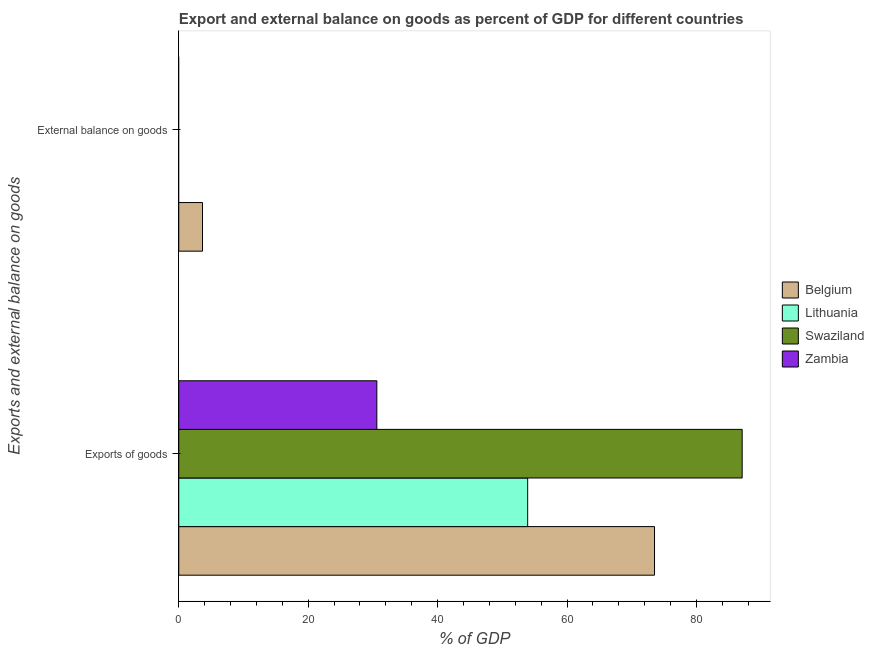Are the number of bars on each tick of the Y-axis equal?
Provide a succinct answer. No. How many bars are there on the 2nd tick from the bottom?
Make the answer very short. 1. What is the label of the 2nd group of bars from the top?
Provide a succinct answer. Exports of goods. What is the external balance on goods as percentage of gdp in Belgium?
Your answer should be very brief. 3.67. Across all countries, what is the maximum export of goods as percentage of gdp?
Provide a short and direct response. 87.07. Across all countries, what is the minimum export of goods as percentage of gdp?
Make the answer very short. 30.61. What is the total export of goods as percentage of gdp in the graph?
Make the answer very short. 245.12. What is the difference between the export of goods as percentage of gdp in Lithuania and that in Belgium?
Your answer should be compact. -19.6. What is the difference between the export of goods as percentage of gdp in Belgium and the external balance on goods as percentage of gdp in Swaziland?
Keep it short and to the point. 73.52. What is the average external balance on goods as percentage of gdp per country?
Provide a short and direct response. 0.92. What is the difference between the export of goods as percentage of gdp and external balance on goods as percentage of gdp in Belgium?
Your answer should be very brief. 69.85. In how many countries, is the external balance on goods as percentage of gdp greater than 36 %?
Your answer should be very brief. 0. What is the ratio of the export of goods as percentage of gdp in Lithuania to that in Zambia?
Ensure brevity in your answer.  1.76. In how many countries, is the export of goods as percentage of gdp greater than the average export of goods as percentage of gdp taken over all countries?
Offer a very short reply. 2. How many countries are there in the graph?
Provide a short and direct response. 4. What is the difference between two consecutive major ticks on the X-axis?
Your answer should be compact. 20. Are the values on the major ticks of X-axis written in scientific E-notation?
Offer a terse response. No. Does the graph contain any zero values?
Your response must be concise. Yes. Does the graph contain grids?
Provide a succinct answer. No. Where does the legend appear in the graph?
Offer a very short reply. Center right. How many legend labels are there?
Offer a very short reply. 4. What is the title of the graph?
Provide a succinct answer. Export and external balance on goods as percent of GDP for different countries. What is the label or title of the X-axis?
Provide a succinct answer. % of GDP. What is the label or title of the Y-axis?
Provide a succinct answer. Exports and external balance on goods. What is the % of GDP in Belgium in Exports of goods?
Your response must be concise. 73.52. What is the % of GDP of Lithuania in Exports of goods?
Your answer should be compact. 53.92. What is the % of GDP in Swaziland in Exports of goods?
Provide a short and direct response. 87.07. What is the % of GDP in Zambia in Exports of goods?
Give a very brief answer. 30.61. What is the % of GDP in Belgium in External balance on goods?
Make the answer very short. 3.67. What is the % of GDP in Swaziland in External balance on goods?
Provide a short and direct response. 0. Across all Exports and external balance on goods, what is the maximum % of GDP in Belgium?
Give a very brief answer. 73.52. Across all Exports and external balance on goods, what is the maximum % of GDP in Lithuania?
Your answer should be very brief. 53.92. Across all Exports and external balance on goods, what is the maximum % of GDP in Swaziland?
Your answer should be compact. 87.07. Across all Exports and external balance on goods, what is the maximum % of GDP in Zambia?
Keep it short and to the point. 30.61. Across all Exports and external balance on goods, what is the minimum % of GDP of Belgium?
Give a very brief answer. 3.67. What is the total % of GDP of Belgium in the graph?
Provide a short and direct response. 77.19. What is the total % of GDP in Lithuania in the graph?
Keep it short and to the point. 53.92. What is the total % of GDP of Swaziland in the graph?
Provide a succinct answer. 87.07. What is the total % of GDP in Zambia in the graph?
Offer a very short reply. 30.61. What is the difference between the % of GDP of Belgium in Exports of goods and that in External balance on goods?
Provide a succinct answer. 69.86. What is the average % of GDP of Belgium per Exports and external balance on goods?
Provide a short and direct response. 38.59. What is the average % of GDP in Lithuania per Exports and external balance on goods?
Keep it short and to the point. 26.96. What is the average % of GDP of Swaziland per Exports and external balance on goods?
Your answer should be compact. 43.53. What is the average % of GDP in Zambia per Exports and external balance on goods?
Your answer should be very brief. 15.31. What is the difference between the % of GDP of Belgium and % of GDP of Lithuania in Exports of goods?
Make the answer very short. 19.6. What is the difference between the % of GDP of Belgium and % of GDP of Swaziland in Exports of goods?
Your answer should be very brief. -13.55. What is the difference between the % of GDP in Belgium and % of GDP in Zambia in Exports of goods?
Make the answer very short. 42.91. What is the difference between the % of GDP of Lithuania and % of GDP of Swaziland in Exports of goods?
Give a very brief answer. -33.15. What is the difference between the % of GDP in Lithuania and % of GDP in Zambia in Exports of goods?
Ensure brevity in your answer.  23.31. What is the difference between the % of GDP of Swaziland and % of GDP of Zambia in Exports of goods?
Your answer should be very brief. 56.46. What is the ratio of the % of GDP of Belgium in Exports of goods to that in External balance on goods?
Provide a succinct answer. 20.05. What is the difference between the highest and the second highest % of GDP in Belgium?
Keep it short and to the point. 69.86. What is the difference between the highest and the lowest % of GDP in Belgium?
Keep it short and to the point. 69.86. What is the difference between the highest and the lowest % of GDP in Lithuania?
Your response must be concise. 53.92. What is the difference between the highest and the lowest % of GDP in Swaziland?
Give a very brief answer. 87.07. What is the difference between the highest and the lowest % of GDP in Zambia?
Make the answer very short. 30.61. 